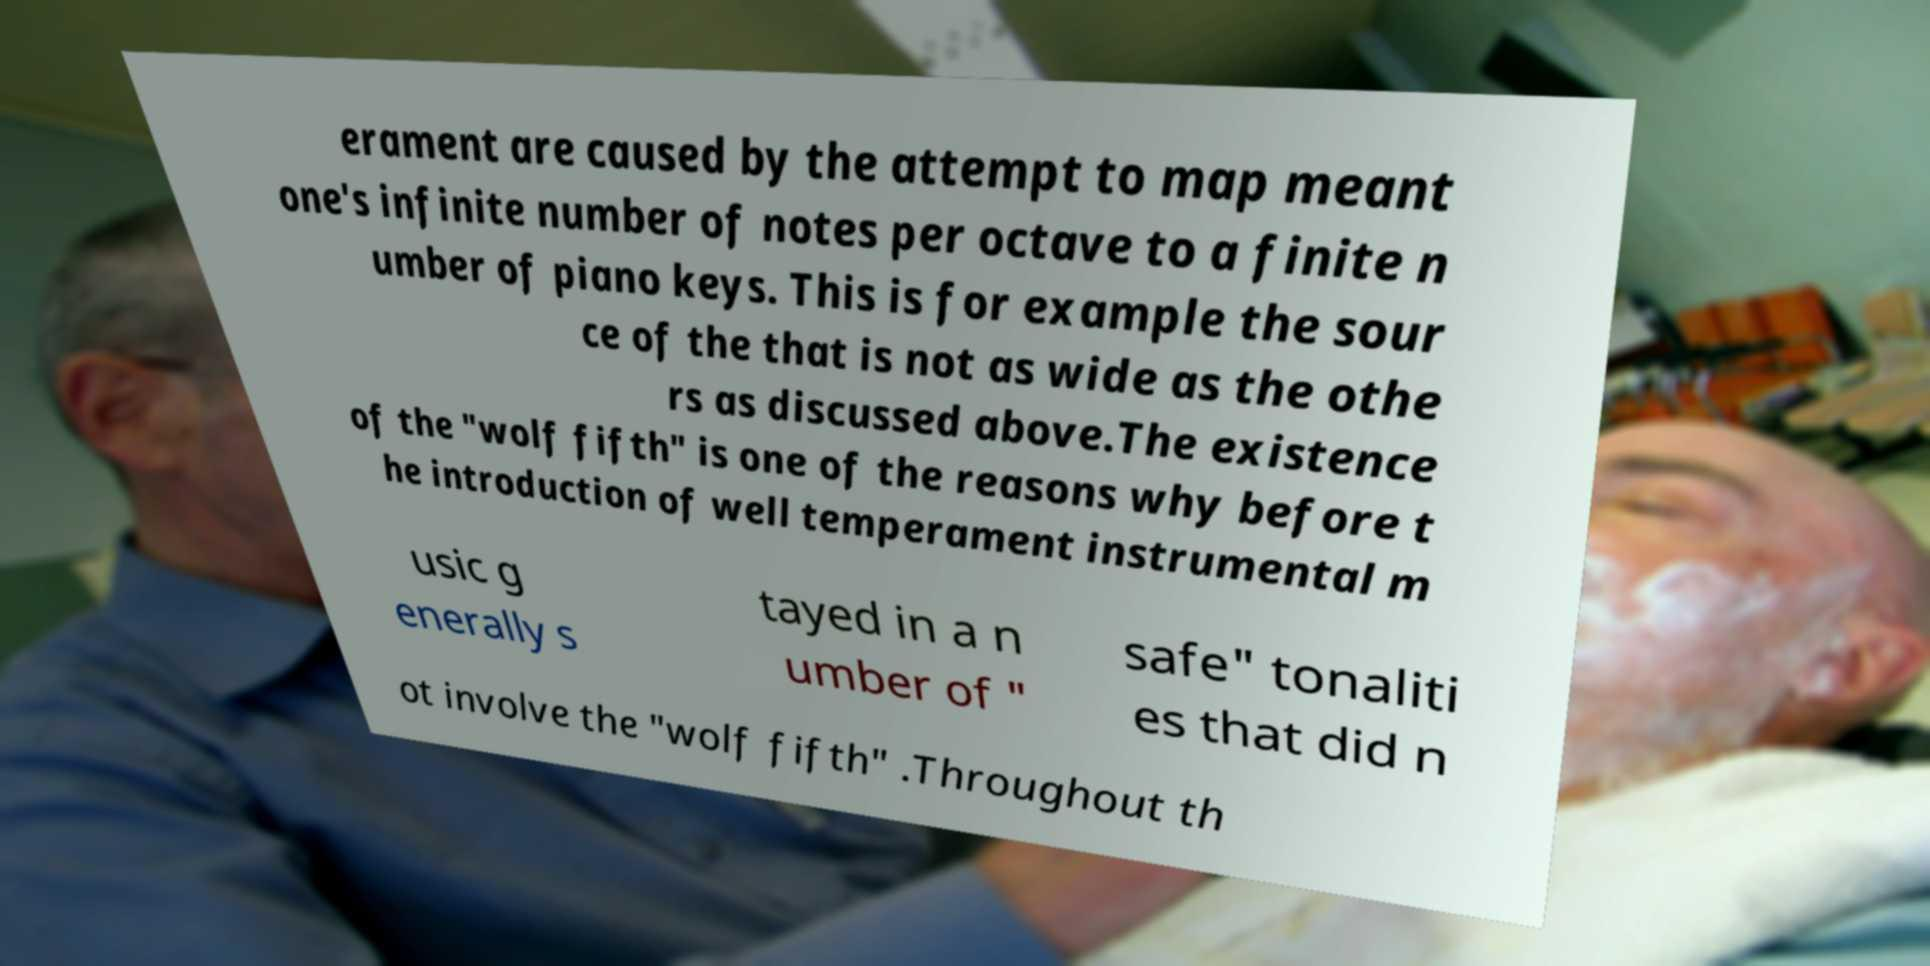Please identify and transcribe the text found in this image. erament are caused by the attempt to map meant one's infinite number of notes per octave to a finite n umber of piano keys. This is for example the sour ce of the that is not as wide as the othe rs as discussed above.The existence of the "wolf fifth" is one of the reasons why before t he introduction of well temperament instrumental m usic g enerally s tayed in a n umber of " safe" tonaliti es that did n ot involve the "wolf fifth" .Throughout th 